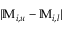<formula> <loc_0><loc_0><loc_500><loc_500>| \mathbb { M } _ { i , u } - \mathbb { M } _ { i , l } |</formula> 